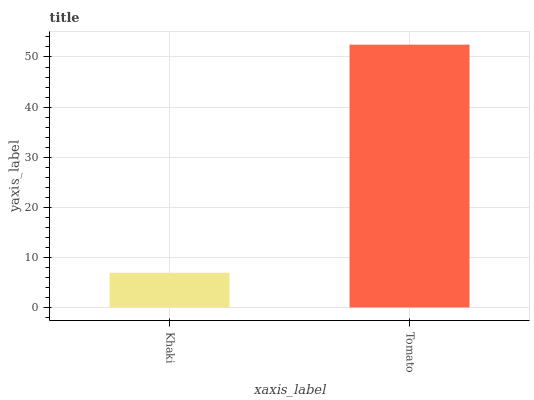Is Tomato the minimum?
Answer yes or no. No. Is Tomato greater than Khaki?
Answer yes or no. Yes. Is Khaki less than Tomato?
Answer yes or no. Yes. Is Khaki greater than Tomato?
Answer yes or no. No. Is Tomato less than Khaki?
Answer yes or no. No. Is Tomato the high median?
Answer yes or no. Yes. Is Khaki the low median?
Answer yes or no. Yes. Is Khaki the high median?
Answer yes or no. No. Is Tomato the low median?
Answer yes or no. No. 